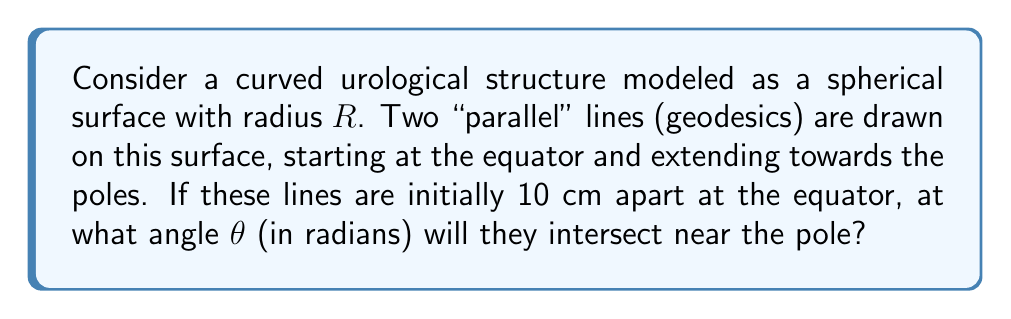Show me your answer to this math problem. Let's approach this step-by-step:

1) In spherical geometry, "parallel" lines (geodesics) always intersect at the poles. This is a key difference from Euclidean geometry, where the parallel postulate states that parallel lines never intersect.

2) On a sphere, the sum of the angles in a triangle is always greater than 180°. The excess over 180° is proportional to the area of the triangle.

3) Consider the triangle formed by our two "parallel" lines and the equator. This is a special case of a spherical triangle where two sides are quarter-circles (from equator to pole).

4) The area of this spherical triangle is given by the formula:
   $$A = R^2(\alpha + \beta + \gamma - \pi)$$
   where $\alpha$, $\beta$, and $\gamma$ are the angles of the triangle in radians, and $R$ is the radius of the sphere.

5) In our case, the angle at the equator is $\frac{\pi}{2}$, and the other two angles are equal (let's call this angle $\theta$). So:
   $$A = R^2(2\theta + \frac{\pi}{2} - \pi) = R^2(2\theta - \frac{\pi}{2})$$

6) We can also calculate the area using the initial separation at the equator:
   $$A = \frac{10}{2\pi R} \cdot \pi R^2 = 5R$$

7) Equating these two expressions for the area:
   $$R^2(2\theta - \frac{\pi}{2}) = 5R$$

8) Solving for $\theta$:
   $$2\theta - \frac{\pi}{2} = \frac{5}{R}$$
   $$2\theta = \frac{5}{R} + \frac{\pi}{2}$$
   $$\theta = \frac{5}{2R} + \frac{\pi}{4}$$

This formula gives us the angle of intersection in terms of the radius $R$ of the spherical surface.
Answer: $\theta = \frac{5}{2R} + \frac{\pi}{4}$ radians 